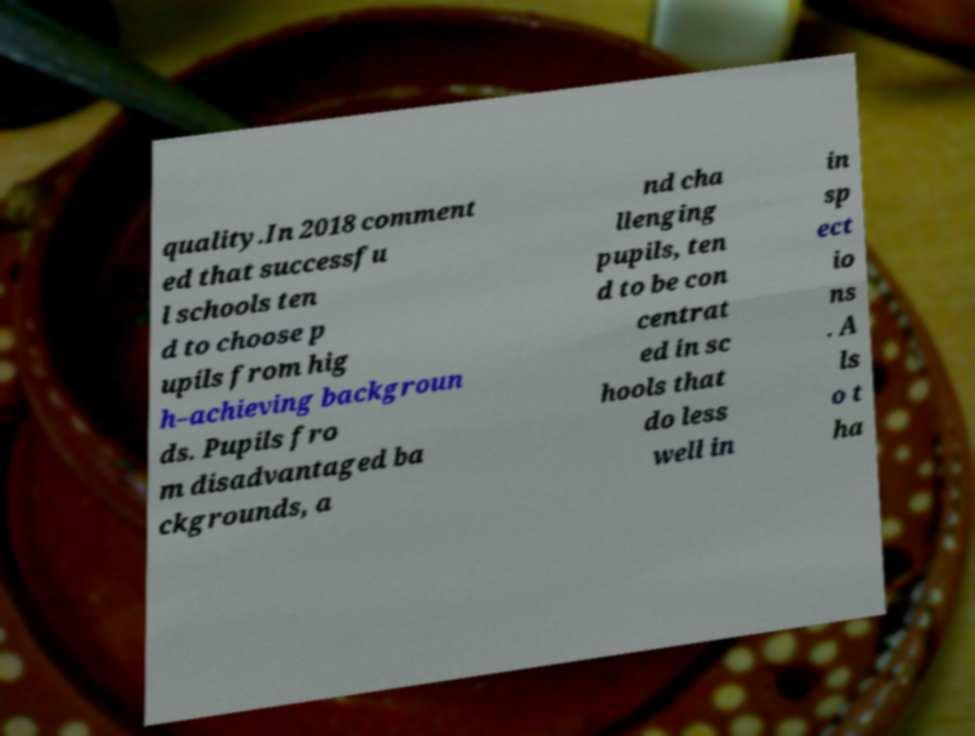There's text embedded in this image that I need extracted. Can you transcribe it verbatim? quality.In 2018 comment ed that successfu l schools ten d to choose p upils from hig h–achieving backgroun ds. Pupils fro m disadvantaged ba ckgrounds, a nd cha llenging pupils, ten d to be con centrat ed in sc hools that do less well in in sp ect io ns . A ls o t ha 